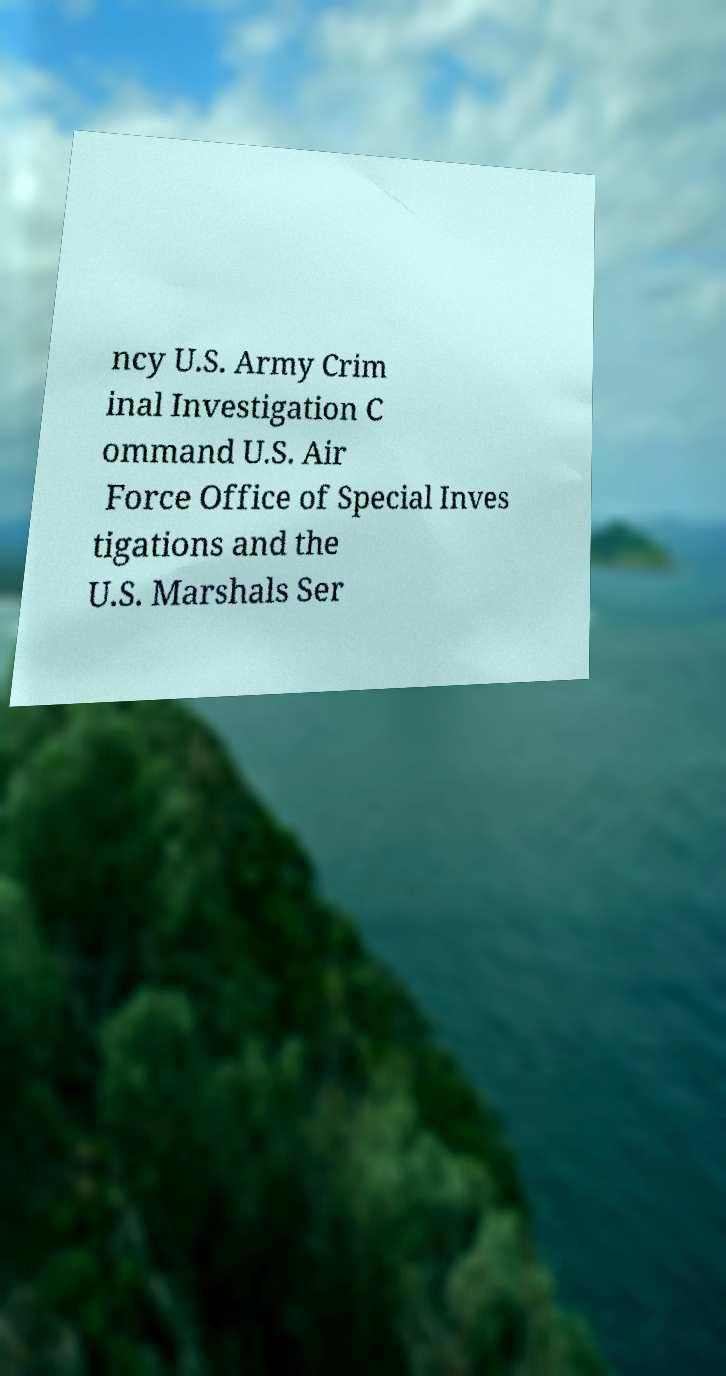Could you extract and type out the text from this image? ncy U.S. Army Crim inal Investigation C ommand U.S. Air Force Office of Special Inves tigations and the U.S. Marshals Ser 